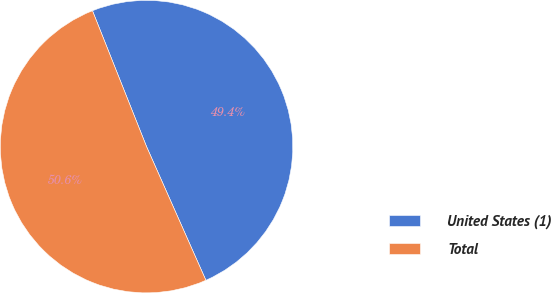Convert chart. <chart><loc_0><loc_0><loc_500><loc_500><pie_chart><fcel>United States (1)<fcel>Total<nl><fcel>49.38%<fcel>50.62%<nl></chart> 